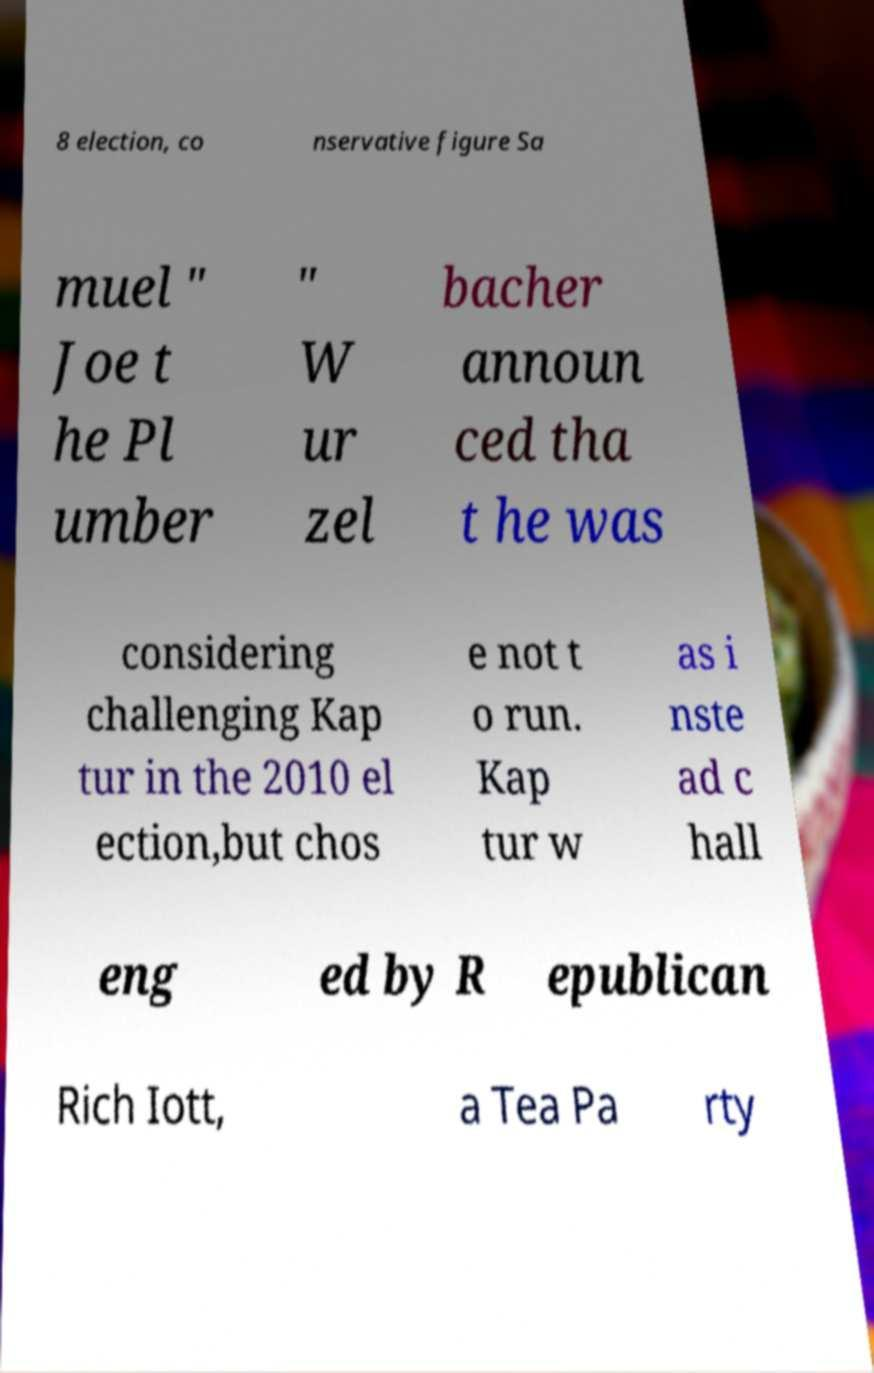What messages or text are displayed in this image? I need them in a readable, typed format. 8 election, co nservative figure Sa muel " Joe t he Pl umber " W ur zel bacher announ ced tha t he was considering challenging Kap tur in the 2010 el ection,but chos e not t o run. Kap tur w as i nste ad c hall eng ed by R epublican Rich Iott, a Tea Pa rty 